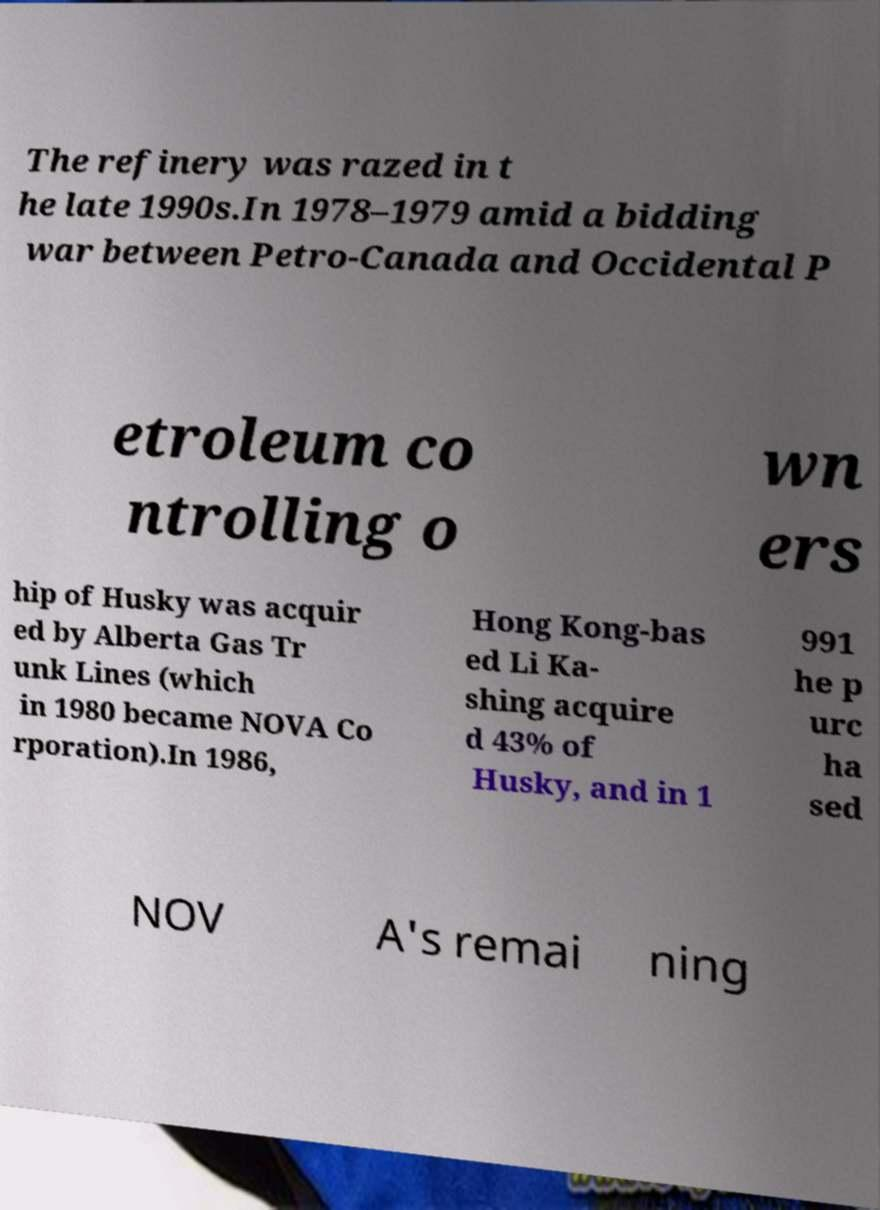Could you extract and type out the text from this image? The refinery was razed in t he late 1990s.In 1978–1979 amid a bidding war between Petro-Canada and Occidental P etroleum co ntrolling o wn ers hip of Husky was acquir ed by Alberta Gas Tr unk Lines (which in 1980 became NOVA Co rporation).In 1986, Hong Kong-bas ed Li Ka- shing acquire d 43% of Husky, and in 1 991 he p urc ha sed NOV A's remai ning 